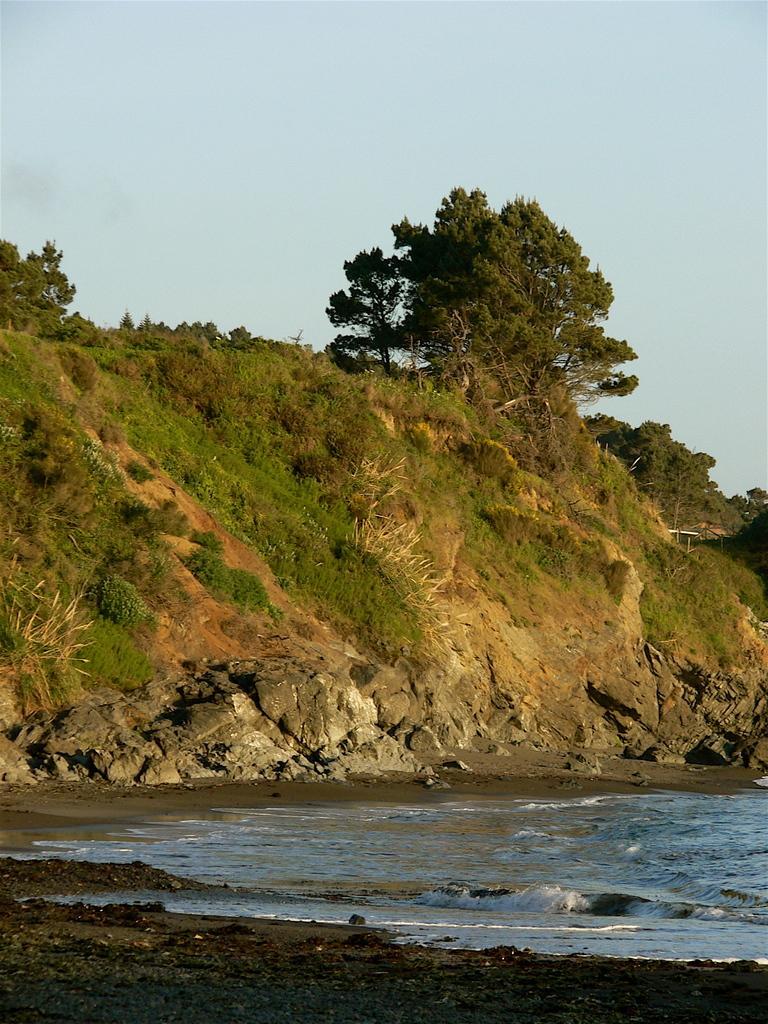Please provide a concise description of this image. In the picture I can see trees, plants, the grass and the water. In the background I can see the sky. 